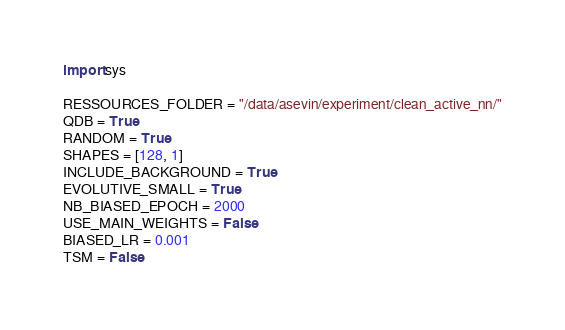<code> <loc_0><loc_0><loc_500><loc_500><_Python_>import sys

RESSOURCES_FOLDER = "/data/asevin/experiment/clean_active_nn/"
QDB = True
RANDOM = True
SHAPES = [128, 1]
INCLUDE_BACKGROUND = True
EVOLUTIVE_SMALL = True
NB_BIASED_EPOCH = 2000
USE_MAIN_WEIGHTS = False
BIASED_LR = 0.001
TSM = False</code> 